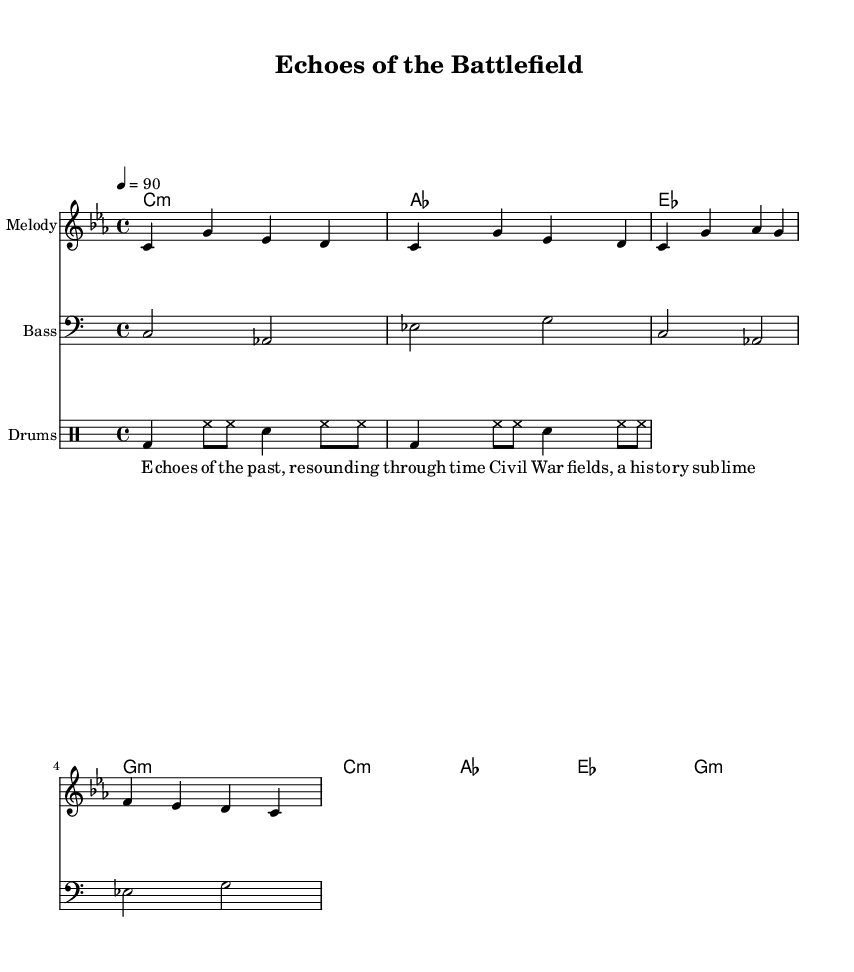What is the key signature of this music? The key signature is C minor, which includes three flats (B♭, E♭, A♭). This is indicated by the key signature shown at the beginning of the score.
Answer: C minor What is the time signature of this music? The time signature is shown as 4/4, meaning there are four beats in each measure, and the quarter note gets one beat. This is typically represented at the beginning of the score.
Answer: 4/4 What is the tempo marking for this piece? The tempo marking specifies the speed of the piece, which is set at 90 beats per minute. This is indicated at the top of the score, helping musicians understand how fast to play.
Answer: 90 How many measures are in the melody? By counting the distinct groups of notes and rests in the melody part, there are eight measures in total. This count includes the division as shown in the sheet music.
Answer: 8 What type of chords are used in the harmonies section? The harmonies section features minor chords, specifically C minor and G minor as indicated in the chord mode. This is easily deduced from the chord names presented in the staff.
Answer: Minor Which instrument is denoted for the melody? The melody is denoted for a flute. This is specified in the instrument name at the start of the melody staff, helping interpret the music for that specific instrument.
Answer: Melody What theme does the lyrics convey? The lyrics convey a message about remembering the Civil War and its historical significance, as indicated by the words used and their context in the lyrics section of the score.
Answer: Historical significance 